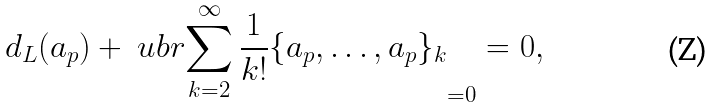Convert formula to latex. <formula><loc_0><loc_0><loc_500><loc_500>d _ { L } ( a _ { p } ) + \ u b r { \sum _ { k = 2 } ^ { \infty } \frac { 1 } { k ! } \{ a _ { p } , \dots , a _ { p } \} _ { k } } _ { = 0 } = 0 ,</formula> 